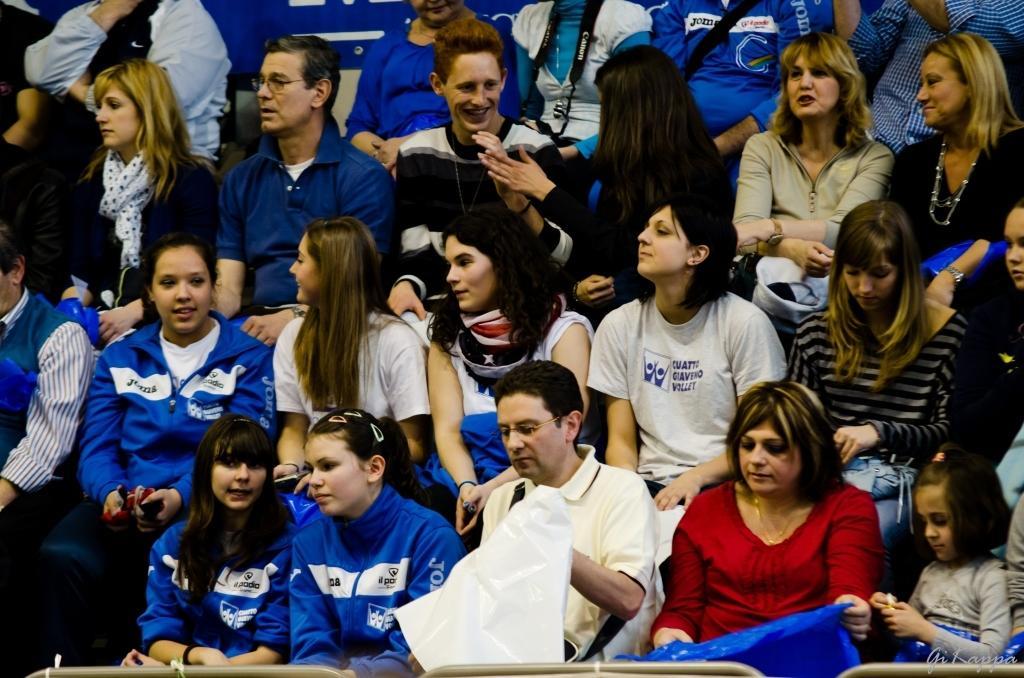Can you describe this image briefly? In this picture we can see a group of people sitting where some are smiling. 